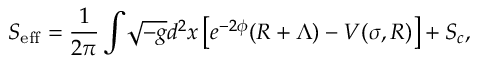<formula> <loc_0><loc_0><loc_500><loc_500>S _ { e f f } = \frac { 1 } { 2 \pi } \int \, \sqrt { - g } d ^ { 2 } x \left [ e ^ { - 2 \phi } ( R + \Lambda ) - V ( \sigma , R ) \right ] + S _ { c } ,</formula> 